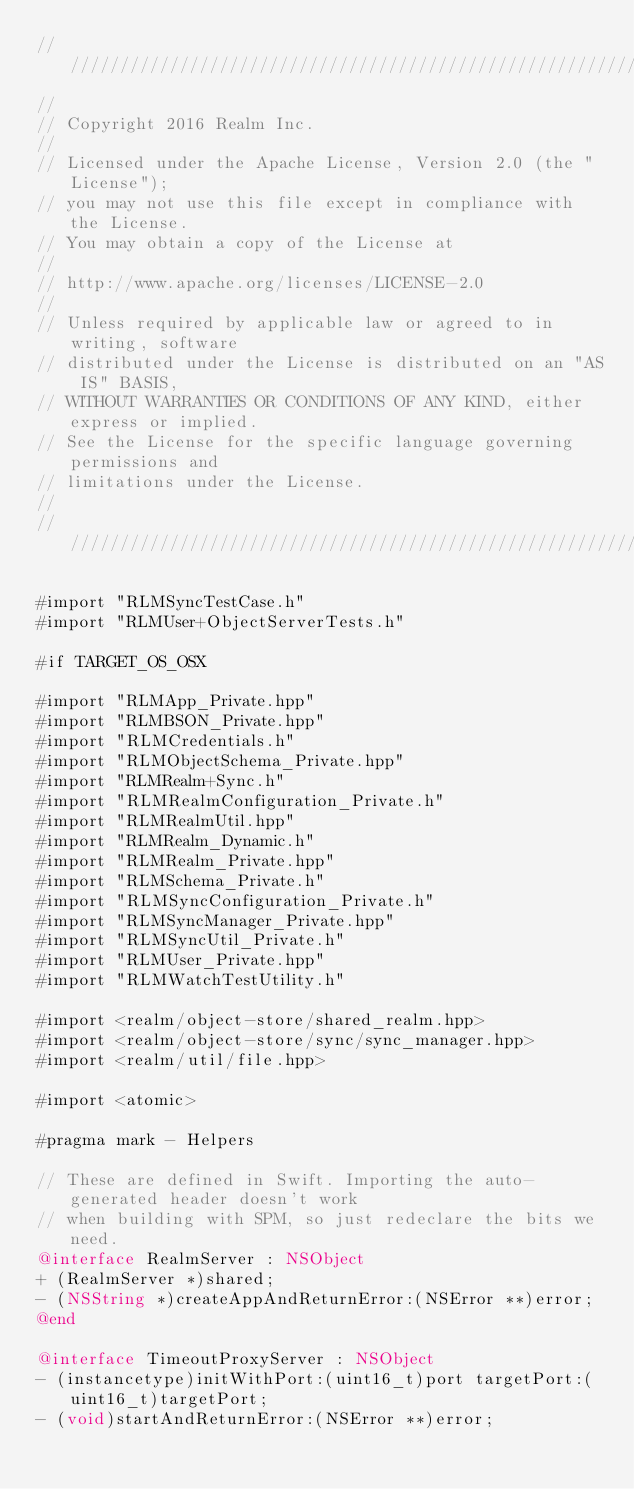<code> <loc_0><loc_0><loc_500><loc_500><_ObjectiveC_>////////////////////////////////////////////////////////////////////////////
//
// Copyright 2016 Realm Inc.
//
// Licensed under the Apache License, Version 2.0 (the "License");
// you may not use this file except in compliance with the License.
// You may obtain a copy of the License at
//
// http://www.apache.org/licenses/LICENSE-2.0
//
// Unless required by applicable law or agreed to in writing, software
// distributed under the License is distributed on an "AS IS" BASIS,
// WITHOUT WARRANTIES OR CONDITIONS OF ANY KIND, either express or implied.
// See the License for the specific language governing permissions and
// limitations under the License.
//
////////////////////////////////////////////////////////////////////////////

#import "RLMSyncTestCase.h"
#import "RLMUser+ObjectServerTests.h"

#if TARGET_OS_OSX

#import "RLMApp_Private.hpp"
#import "RLMBSON_Private.hpp"
#import "RLMCredentials.h"
#import "RLMObjectSchema_Private.hpp"
#import "RLMRealm+Sync.h"
#import "RLMRealmConfiguration_Private.h"
#import "RLMRealmUtil.hpp"
#import "RLMRealm_Dynamic.h"
#import "RLMRealm_Private.hpp"
#import "RLMSchema_Private.h"
#import "RLMSyncConfiguration_Private.h"
#import "RLMSyncManager_Private.hpp"
#import "RLMSyncUtil_Private.h"
#import "RLMUser_Private.hpp"
#import "RLMWatchTestUtility.h"

#import <realm/object-store/shared_realm.hpp>
#import <realm/object-store/sync/sync_manager.hpp>
#import <realm/util/file.hpp>

#import <atomic>

#pragma mark - Helpers

// These are defined in Swift. Importing the auto-generated header doesn't work
// when building with SPM, so just redeclare the bits we need.
@interface RealmServer : NSObject
+ (RealmServer *)shared;
- (NSString *)createAppAndReturnError:(NSError **)error;
@end

@interface TimeoutProxyServer : NSObject
- (instancetype)initWithPort:(uint16_t)port targetPort:(uint16_t)targetPort;
- (void)startAndReturnError:(NSError **)error;</code> 